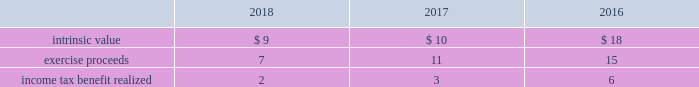The table provides the weighted average assumptions used in the black-scholes option-pricing model for grants and the resulting weighted average grant date fair value per share of stock options granted for the years ended december 31: .
Stock units during 2018 , 2017 and 2016 , the company granted rsus to certain employees under the 2007 plan and 2017 omnibus plan , as applicable .
Rsus generally vest based on continued employment with the company over periods ranging from one to three years. .
By how much did the intrinsic value decrease from 2016 to 2018? 
Computations: ((9 - 18) / 18)
Answer: -0.5. 